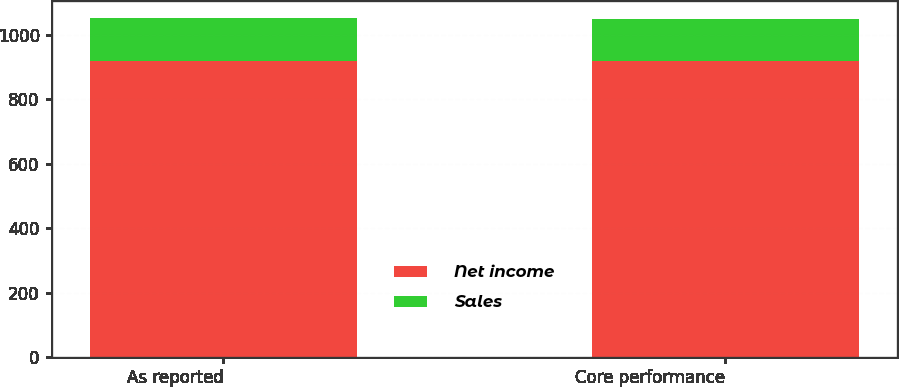<chart> <loc_0><loc_0><loc_500><loc_500><stacked_bar_chart><ecel><fcel>As reported<fcel>Core performance<nl><fcel>Net income<fcel>919<fcel>919<nl><fcel>Sales<fcel>132<fcel>130<nl></chart> 